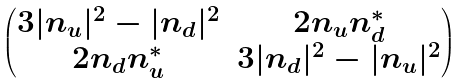Convert formula to latex. <formula><loc_0><loc_0><loc_500><loc_500>\begin{pmatrix} 3 | n _ { u } | ^ { 2 } - | n _ { d } | ^ { 2 } & 2 n _ { u } n _ { d } ^ { * } \\ 2 n _ { d } n _ { u } ^ { * } & 3 | n _ { d } | ^ { 2 } - | n _ { u } | ^ { 2 } \end{pmatrix}</formula> 